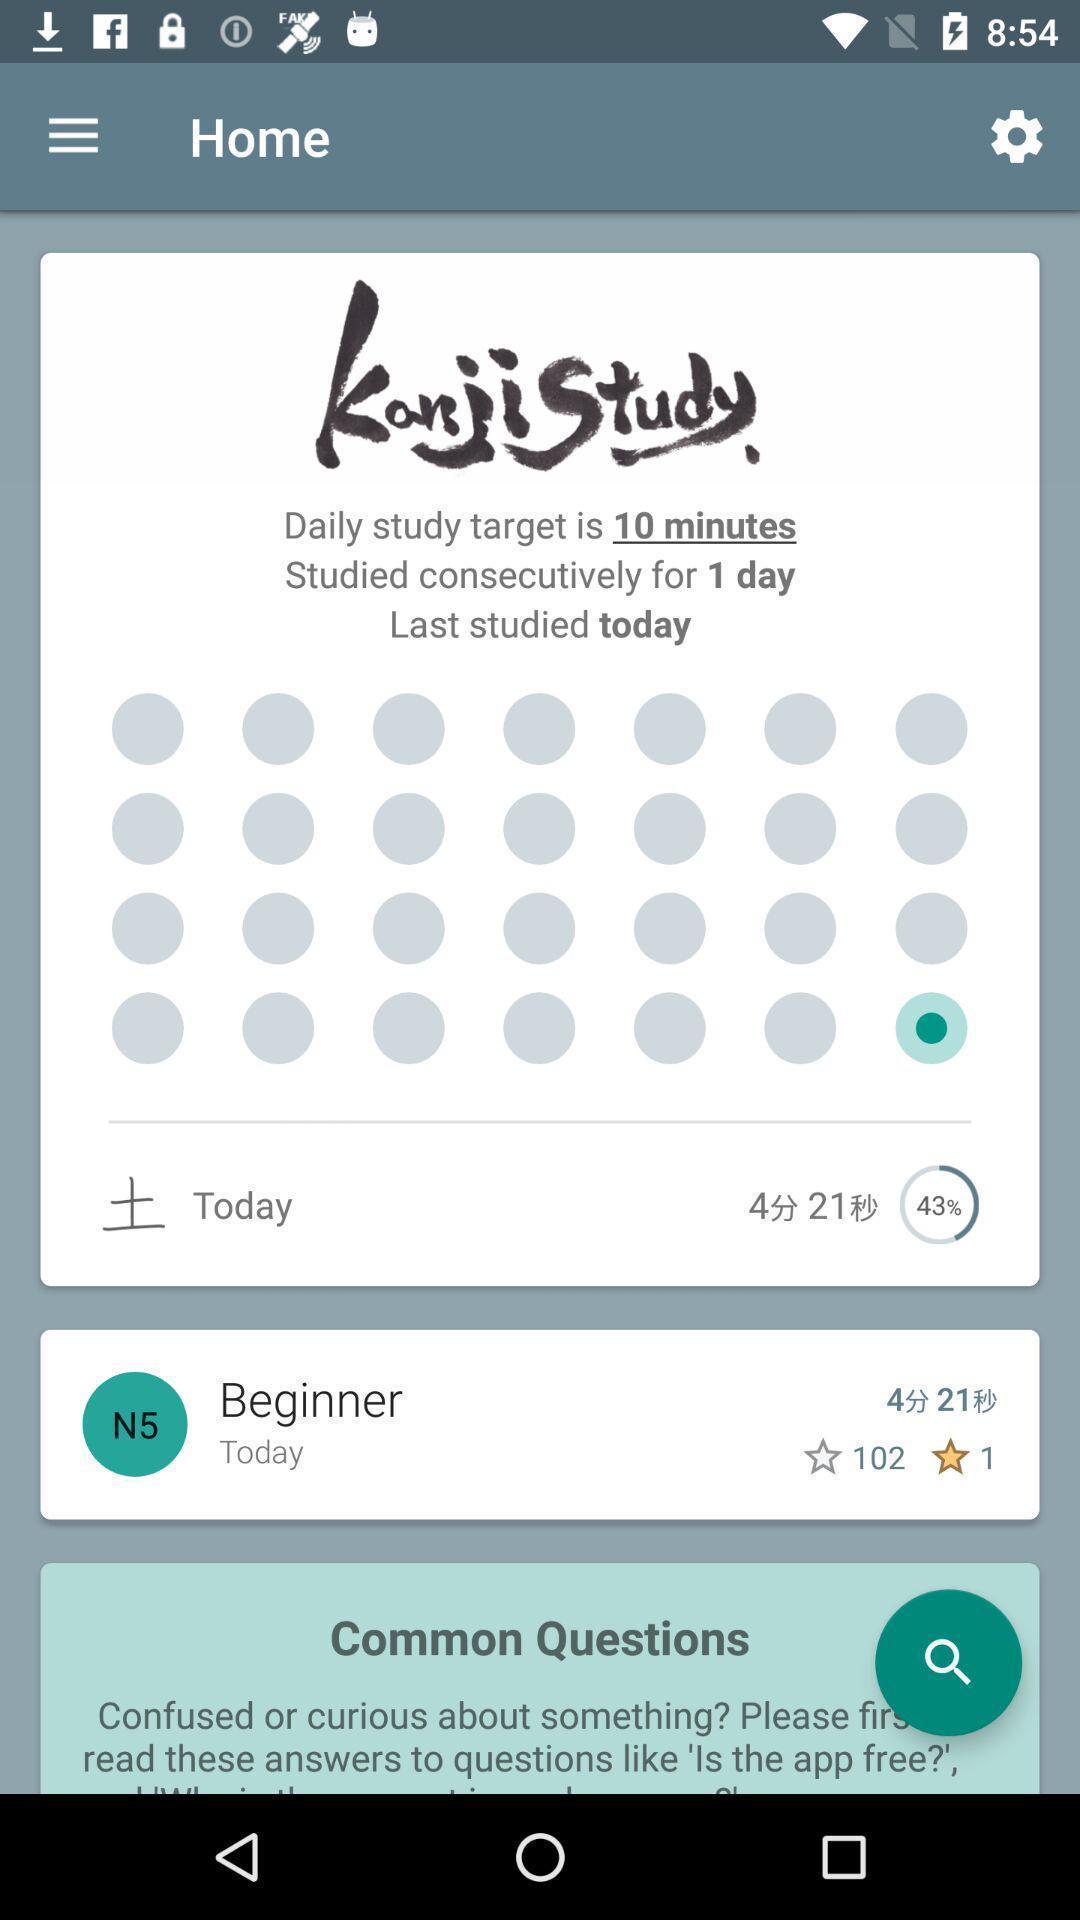Describe this image in words. Screen showing home page of a study material. 